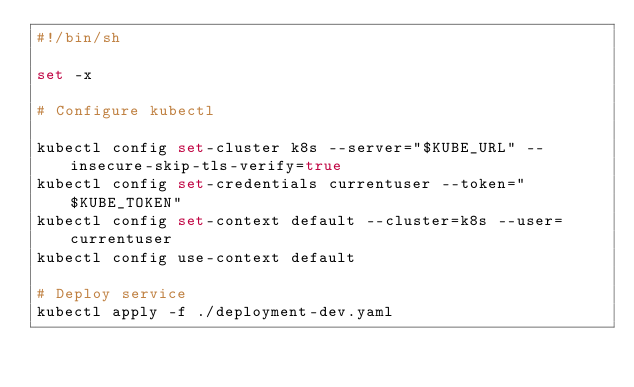Convert code to text. <code><loc_0><loc_0><loc_500><loc_500><_Bash_>#!/bin/sh

set -x

# Configure kubectl

kubectl config set-cluster k8s --server="$KUBE_URL" --insecure-skip-tls-verify=true
kubectl config set-credentials currentuser --token="$KUBE_TOKEN"
kubectl config set-context default --cluster=k8s --user=currentuser
kubectl config use-context default

# Deploy service
kubectl apply -f ./deployment-dev.yaml</code> 